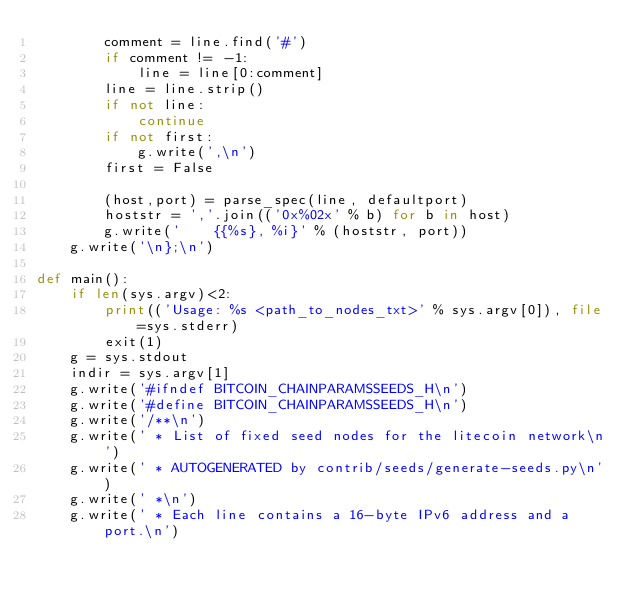<code> <loc_0><loc_0><loc_500><loc_500><_Python_>        comment = line.find('#')
        if comment != -1:
            line = line[0:comment]
        line = line.strip()
        if not line:
            continue
        if not first:
            g.write(',\n')
        first = False

        (host,port) = parse_spec(line, defaultport)
        hoststr = ','.join(('0x%02x' % b) for b in host)
        g.write('    {{%s}, %i}' % (hoststr, port))
    g.write('\n};\n')

def main():
    if len(sys.argv)<2:
        print(('Usage: %s <path_to_nodes_txt>' % sys.argv[0]), file=sys.stderr)
        exit(1)
    g = sys.stdout
    indir = sys.argv[1]
    g.write('#ifndef BITCOIN_CHAINPARAMSSEEDS_H\n')
    g.write('#define BITCOIN_CHAINPARAMSSEEDS_H\n')
    g.write('/**\n')
    g.write(' * List of fixed seed nodes for the litecoin network\n')
    g.write(' * AUTOGENERATED by contrib/seeds/generate-seeds.py\n')
    g.write(' *\n')
    g.write(' * Each line contains a 16-byte IPv6 address and a port.\n')</code> 